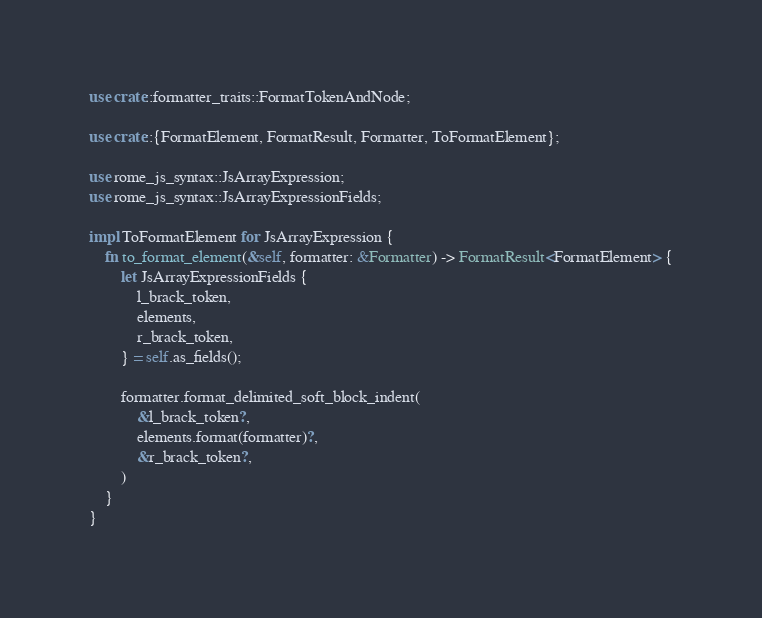<code> <loc_0><loc_0><loc_500><loc_500><_Rust_>use crate::formatter_traits::FormatTokenAndNode;

use crate::{FormatElement, FormatResult, Formatter, ToFormatElement};

use rome_js_syntax::JsArrayExpression;
use rome_js_syntax::JsArrayExpressionFields;

impl ToFormatElement for JsArrayExpression {
    fn to_format_element(&self, formatter: &Formatter) -> FormatResult<FormatElement> {
        let JsArrayExpressionFields {
            l_brack_token,
            elements,
            r_brack_token,
        } = self.as_fields();

        formatter.format_delimited_soft_block_indent(
            &l_brack_token?,
            elements.format(formatter)?,
            &r_brack_token?,
        )
    }
}
</code> 